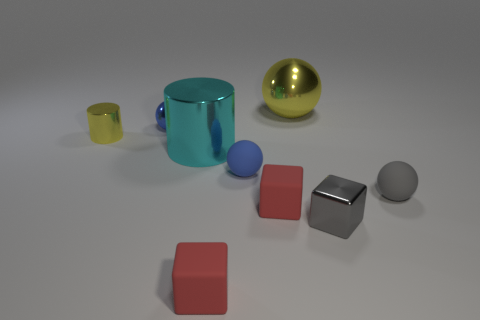Subtract all yellow balls. How many balls are left? 3 Subtract all gray balls. How many balls are left? 3 Subtract 0 blue blocks. How many objects are left? 9 Subtract all balls. How many objects are left? 5 Subtract 3 spheres. How many spheres are left? 1 Subtract all cyan cubes. Subtract all red cylinders. How many cubes are left? 3 Subtract all brown balls. How many brown cubes are left? 0 Subtract all small purple shiny cylinders. Subtract all small cubes. How many objects are left? 6 Add 1 tiny red objects. How many tiny red objects are left? 3 Add 4 small gray metallic things. How many small gray metallic things exist? 5 